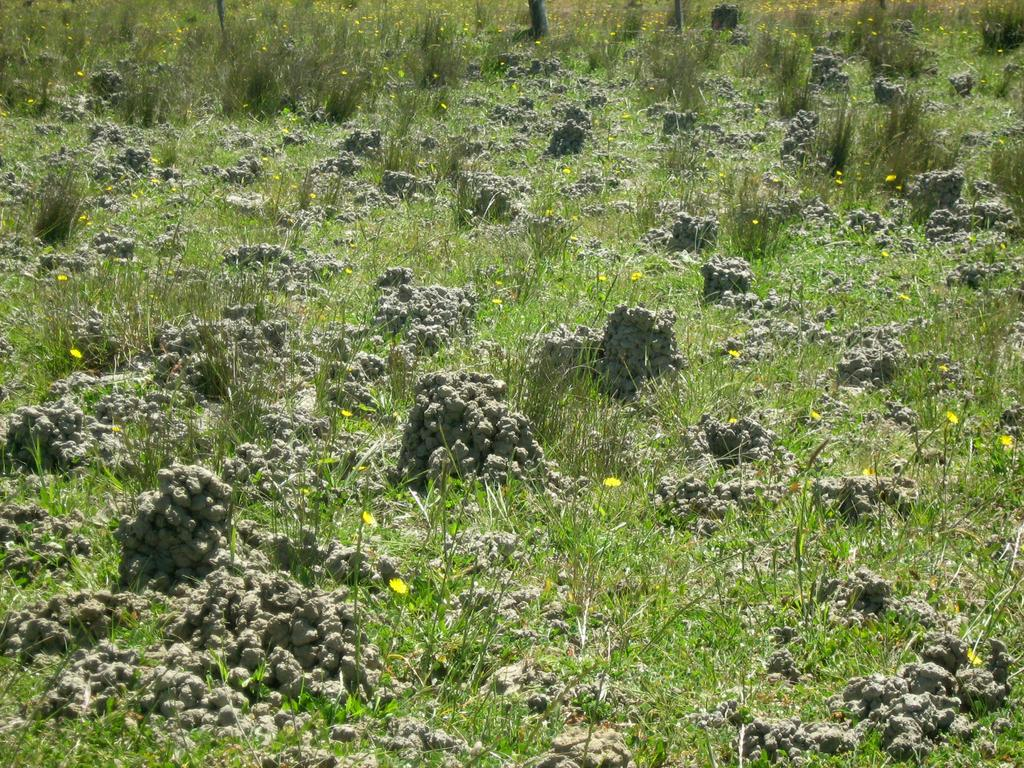Where was the picture taken? The picture was clicked outside. What can be seen in the center of the image? There is green grass and flowers in the center of the image. Are there any other objects visible in the center of the image? Yes, there are other objects visible in the center of the image. Is there a snake slithering through the grass in the image? There is no snake visible in the image; it only shows green grass, flowers, and other unspecified objects. 